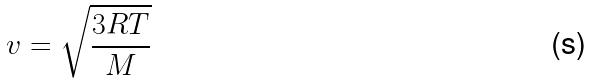Convert formula to latex. <formula><loc_0><loc_0><loc_500><loc_500>v = \sqrt { \frac { 3 R T } { M } }</formula> 